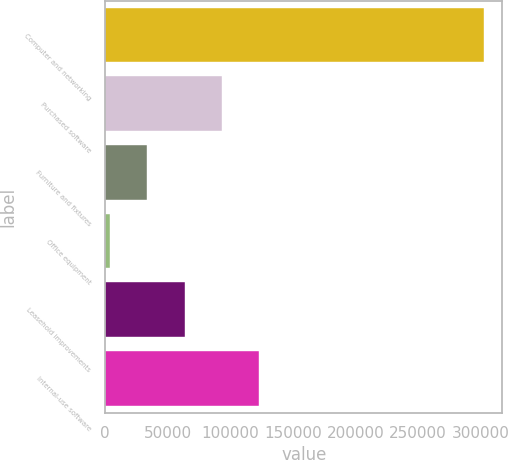Convert chart. <chart><loc_0><loc_0><loc_500><loc_500><bar_chart><fcel>Computer and networking<fcel>Purchased software<fcel>Furniture and fixtures<fcel>Office equipment<fcel>Leasehold improvements<fcel>Internal-use software<nl><fcel>302213<fcel>93347.7<fcel>33671.9<fcel>3834<fcel>63509.8<fcel>123186<nl></chart> 